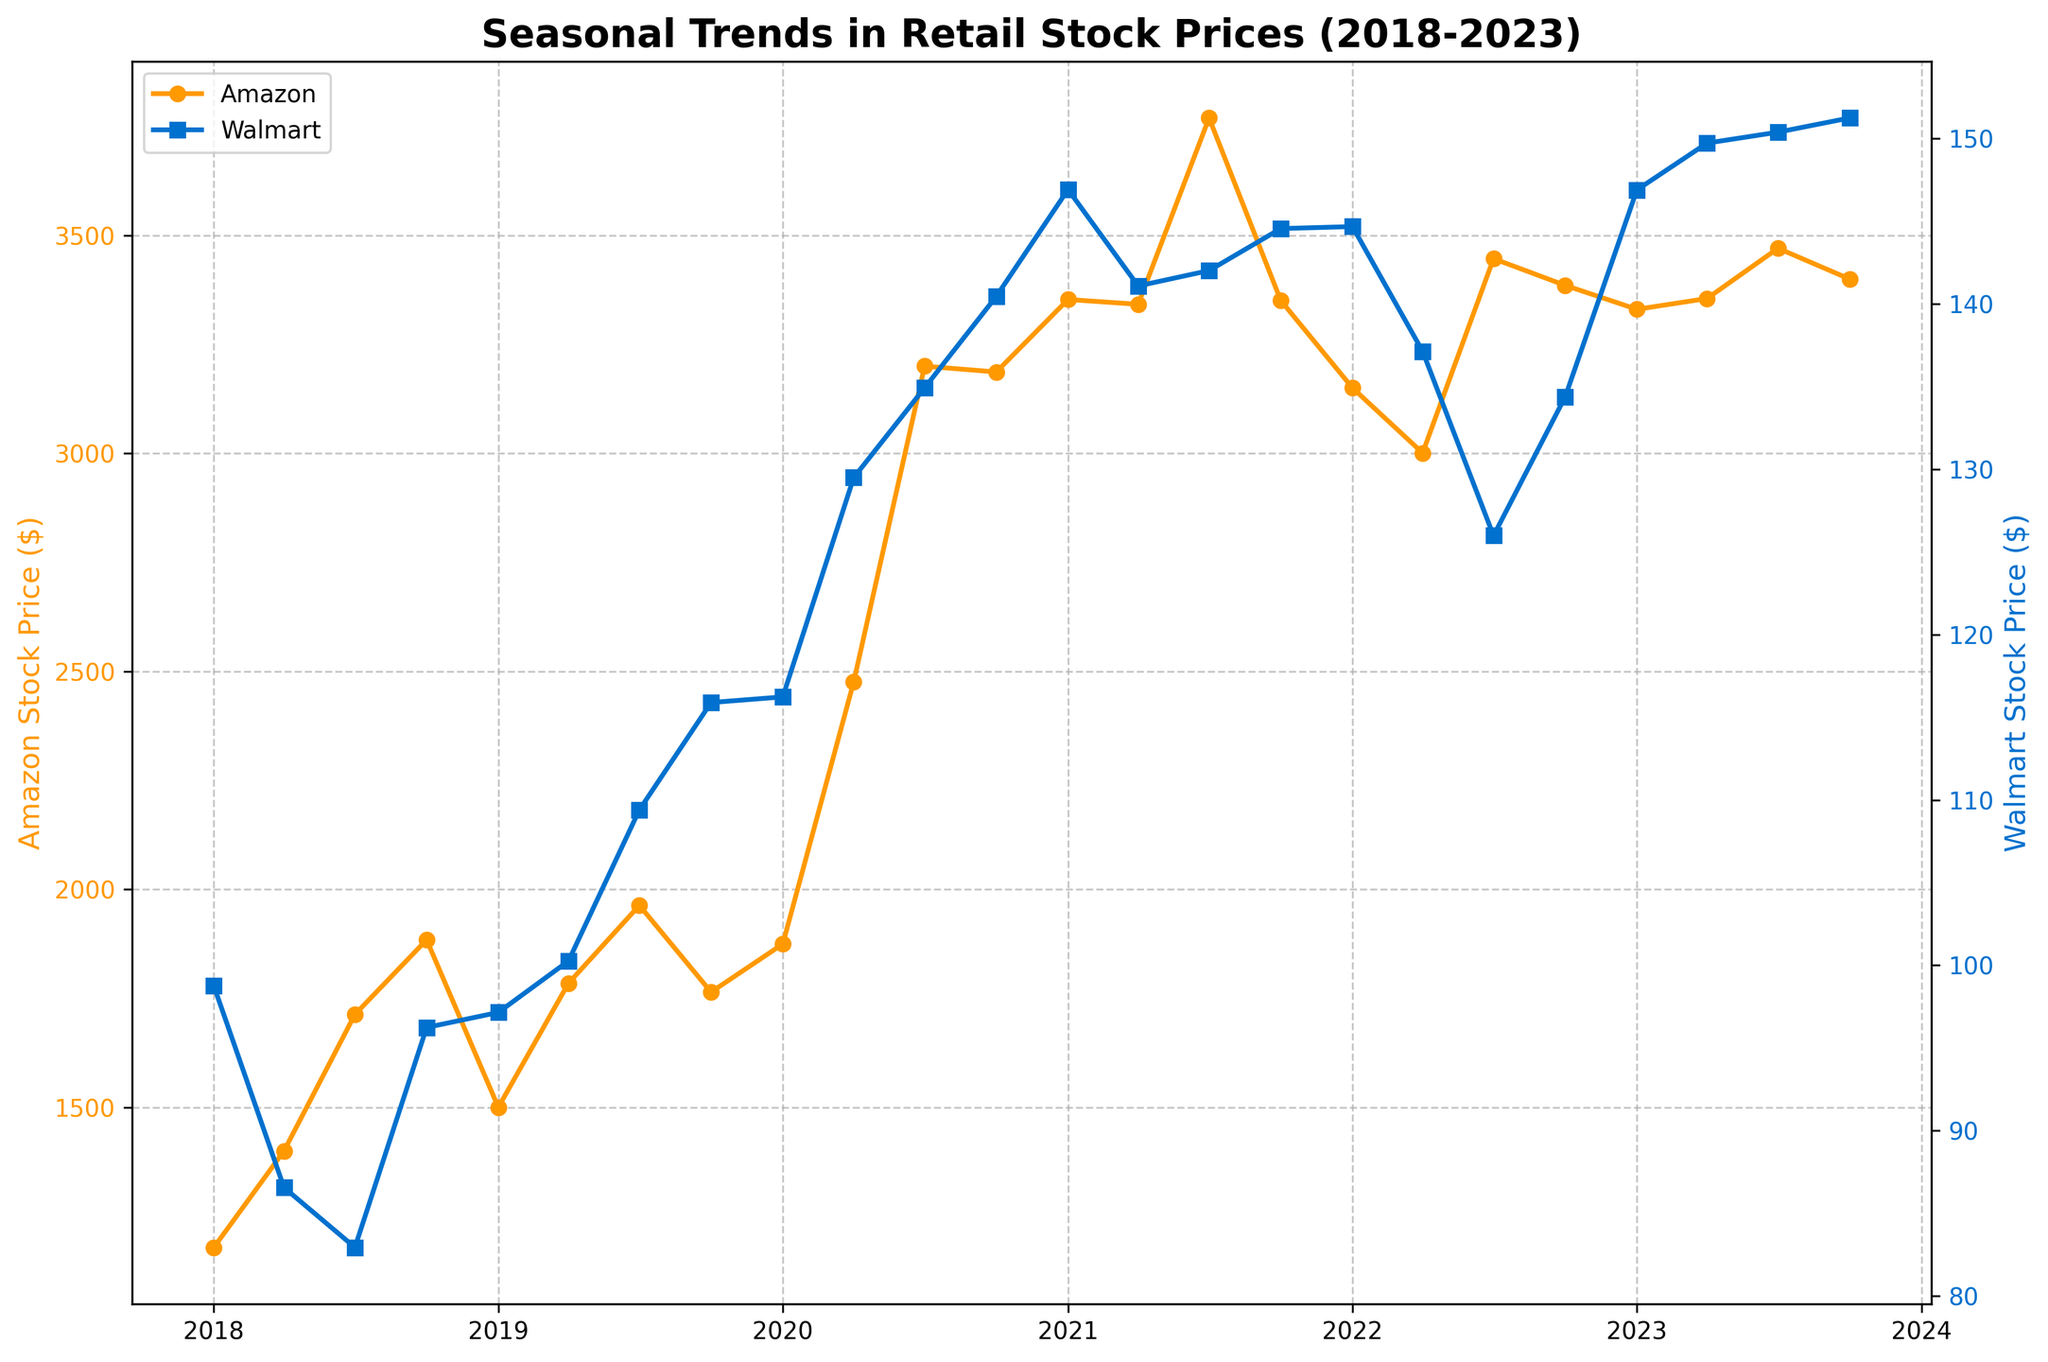What is the title of the plot? The title is usually located at the top of the plot and provides a summary of the information represented. In this case, it is displayed in bold.
Answer: Seasonal Trends in Retail Stock Prices (2018-2023) What are the two companies compared in the plot? To identify the companies, look at the labels in the legend or the y-axes. Different colors represent different companies.
Answer: Amazon and Walmart Which company had a higher stock price peak over the last five years? By examining the highest points on each line plot, we see that Amazon's orange line shows the highest peak.
Answer: Amazon How did Amazon's stock price change from January 2020 to October 2020? Follow the Amazon orange line from January 2020 to October 2020 to see the trend and note the stock prices at these points.
Answer: It increased from 1874.78 to 3186.63 Did Walmart's stock price ever surpass $150? If so, when? Check the blue line representing Walmart and observe the y-axis values. Identify if it crosses the $150 mark and note the dates.
Answer: Yes, in 2023 Comparing January 2020 and January 2021, which company had a higher percentage increase in stock prices? Calculate the percentage increase for both companies between these dates. For Amazon: ((3352.87 - 1874.78) / 1874.78) * 100. For Walmart: ((146.91 - 116.23) / 116.23) * 100, then compare.
Answer: Amazon What are the colors used for Amazon and Walmart in the plot? Identify the colors used for each company's line plot by referring to the legend or observing the lines directly.
Answer: Orange for Amazon and Blue for Walmart During which quarter of which year did Walmart see the largest increase in stock price? Analyze the blue line's slope and pinpoint where the most significant rise occurs.
Answer: Between April and July 2019 At the end of the plotted time period, which company's stock price is higher? Look at the stock prices for both companies in October 2023 and note which is higher.
Answer: Amazon How did Walmart's stock price trend from October 2019 to October 2021? Follow Walmart’s blue line between these dates and describe the overall direction.
Answer: It increased 